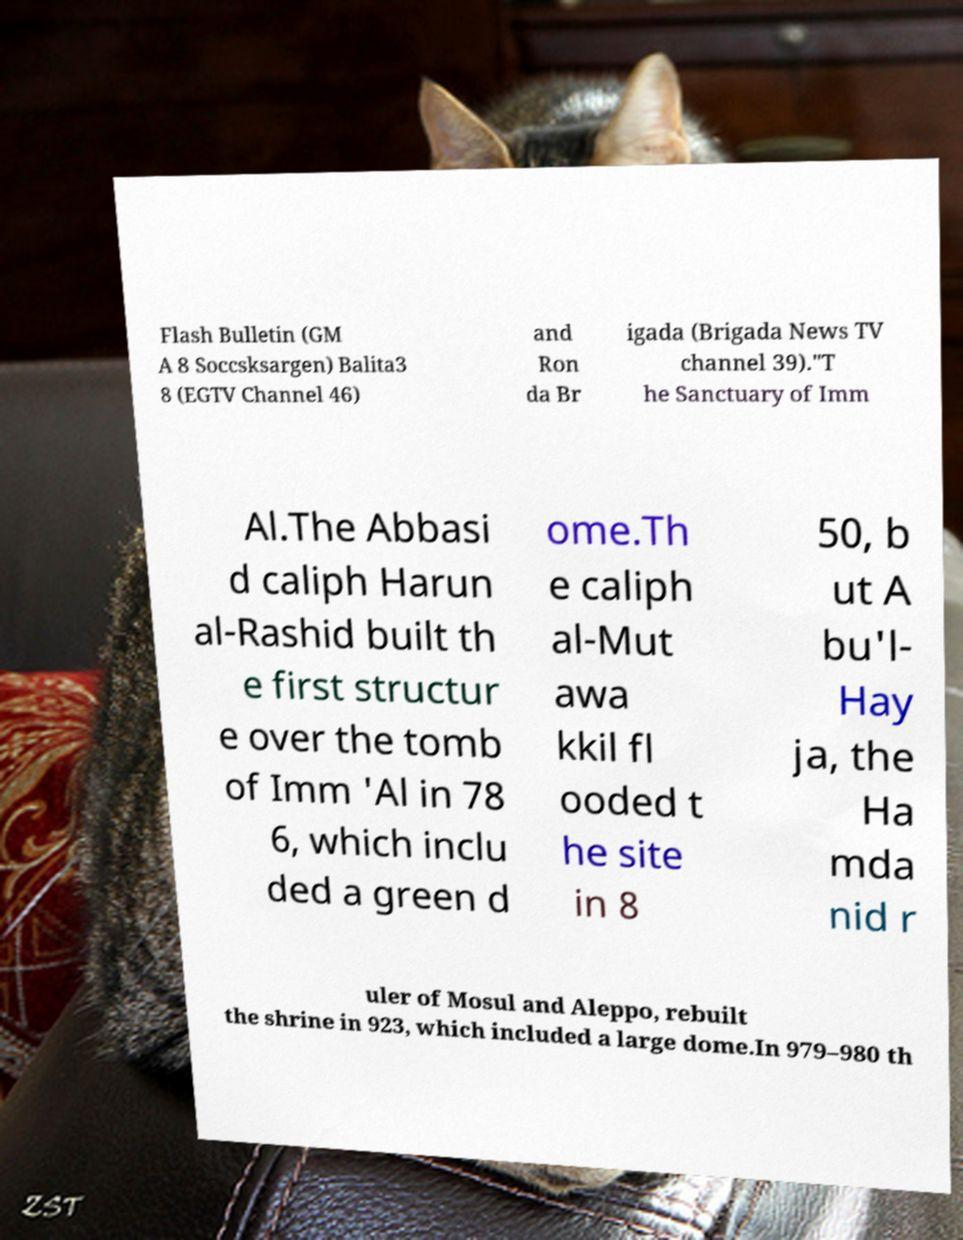What messages or text are displayed in this image? I need them in a readable, typed format. Flash Bulletin (GM A 8 Soccsksargen) Balita3 8 (EGTV Channel 46) and Ron da Br igada (Brigada News TV channel 39)."T he Sanctuary of Imm Al.The Abbasi d caliph Harun al-Rashid built th e first structur e over the tomb of Imm 'Al in 78 6, which inclu ded a green d ome.Th e caliph al-Mut awa kkil fl ooded t he site in 8 50, b ut A bu'l- Hay ja, the Ha mda nid r uler of Mosul and Aleppo, rebuilt the shrine in 923, which included a large dome.In 979–980 th 